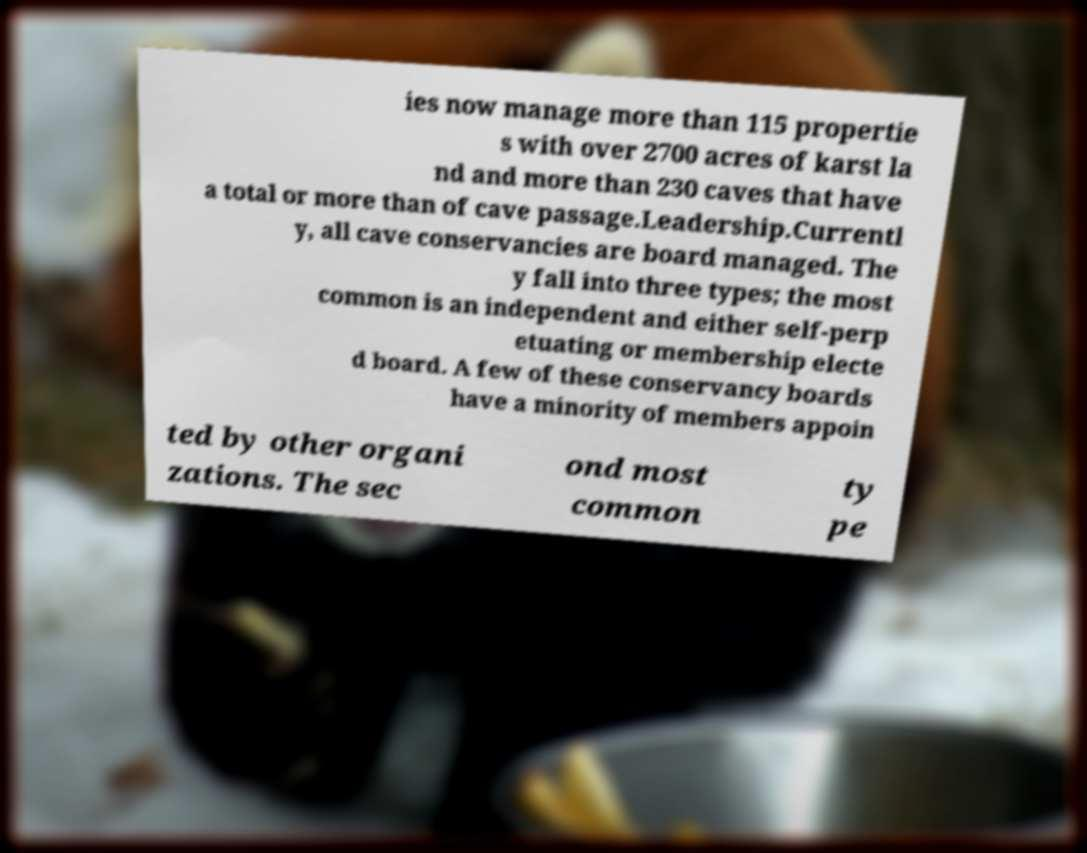Please read and relay the text visible in this image. What does it say? ies now manage more than 115 propertie s with over 2700 acres of karst la nd and more than 230 caves that have a total or more than of cave passage.Leadership.Currentl y, all cave conservancies are board managed. The y fall into three types; the most common is an independent and either self-perp etuating or membership electe d board. A few of these conservancy boards have a minority of members appoin ted by other organi zations. The sec ond most common ty pe 